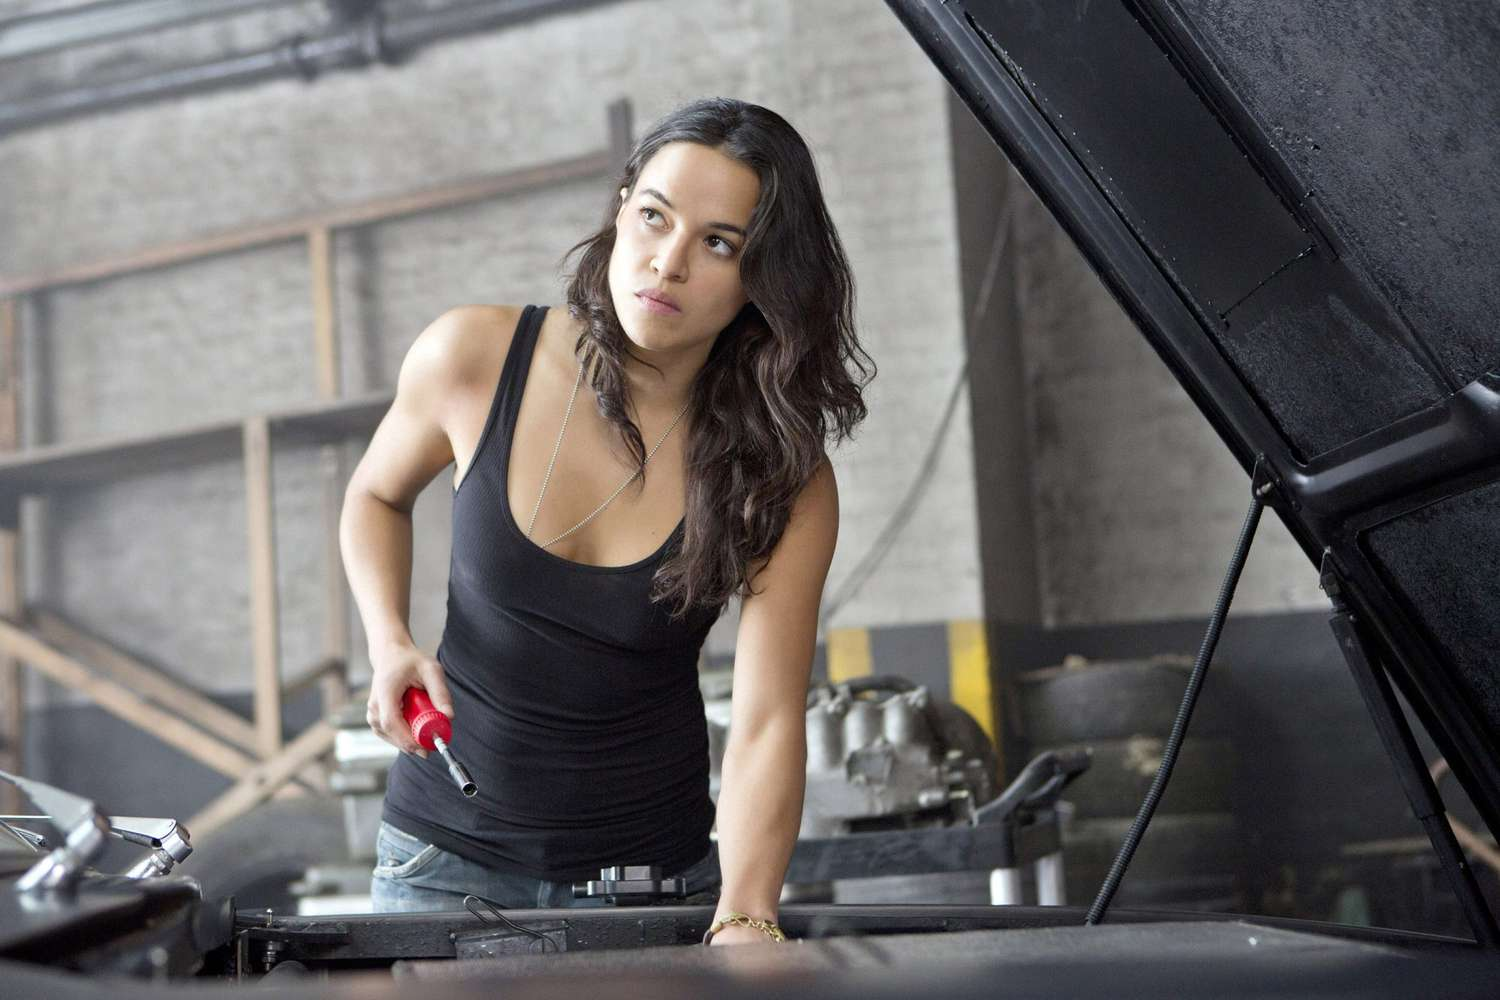Analyze the image in a comprehensive and detailed manner. The image portrays a woman in a garage environment, standing in front of an open car hood. She is wearing a fitted black tank top and blue jeans, exuding a rugged, hands-on attitude. In her right hand, she holds a red wrench, poised and ready to work on the car. The background includes stacked tires and industrial equipment, suggesting this is a busy and practical space dedicated to automotive repair or modification. Her serious and focused expression highlights her concentration, adding to the image's sense of purpose and determination. The lighting is natural, casting soft shadows and highlighting her features and the surrounding garage elements. 